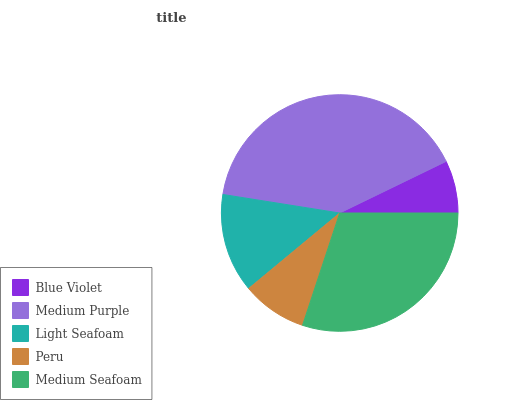Is Blue Violet the minimum?
Answer yes or no. Yes. Is Medium Purple the maximum?
Answer yes or no. Yes. Is Light Seafoam the minimum?
Answer yes or no. No. Is Light Seafoam the maximum?
Answer yes or no. No. Is Medium Purple greater than Light Seafoam?
Answer yes or no. Yes. Is Light Seafoam less than Medium Purple?
Answer yes or no. Yes. Is Light Seafoam greater than Medium Purple?
Answer yes or no. No. Is Medium Purple less than Light Seafoam?
Answer yes or no. No. Is Light Seafoam the high median?
Answer yes or no. Yes. Is Light Seafoam the low median?
Answer yes or no. Yes. Is Peru the high median?
Answer yes or no. No. Is Medium Purple the low median?
Answer yes or no. No. 